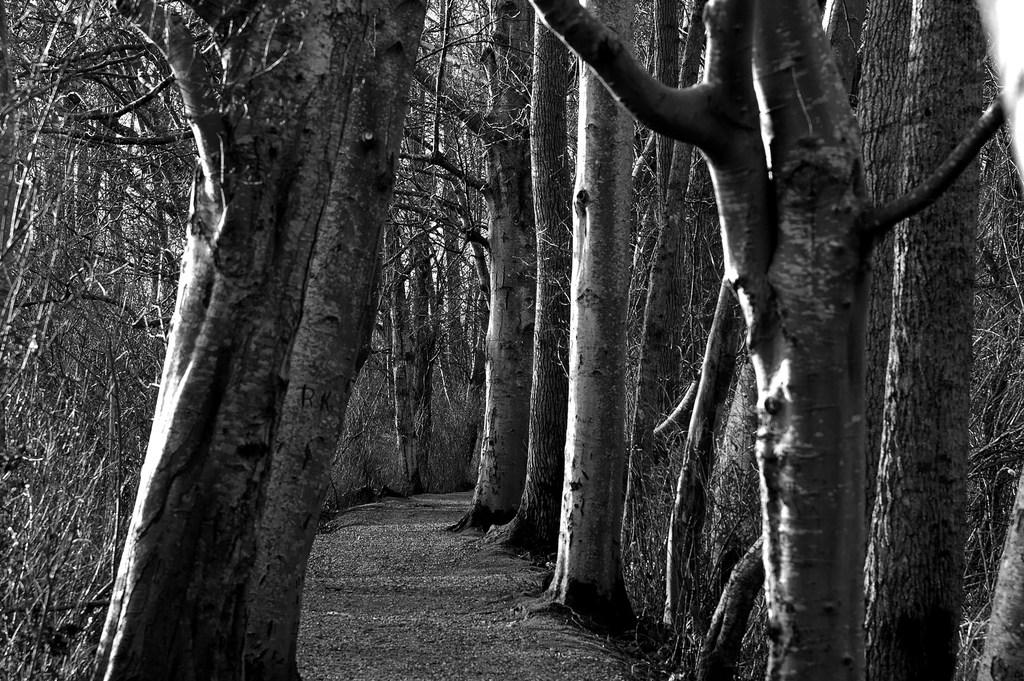What is the color scheme of the image? The image is black and white. What can be seen in the image besides the color scheme? There is a path in the image. What type of vegetation is present along the path? There are trees on either side of the path. How many brushes are visible in the image? There are no brushes present in the image. Are the brothers walking along the path in the image? There is no mention of brothers or any people walking in the image; it only features a path with trees on either side. 